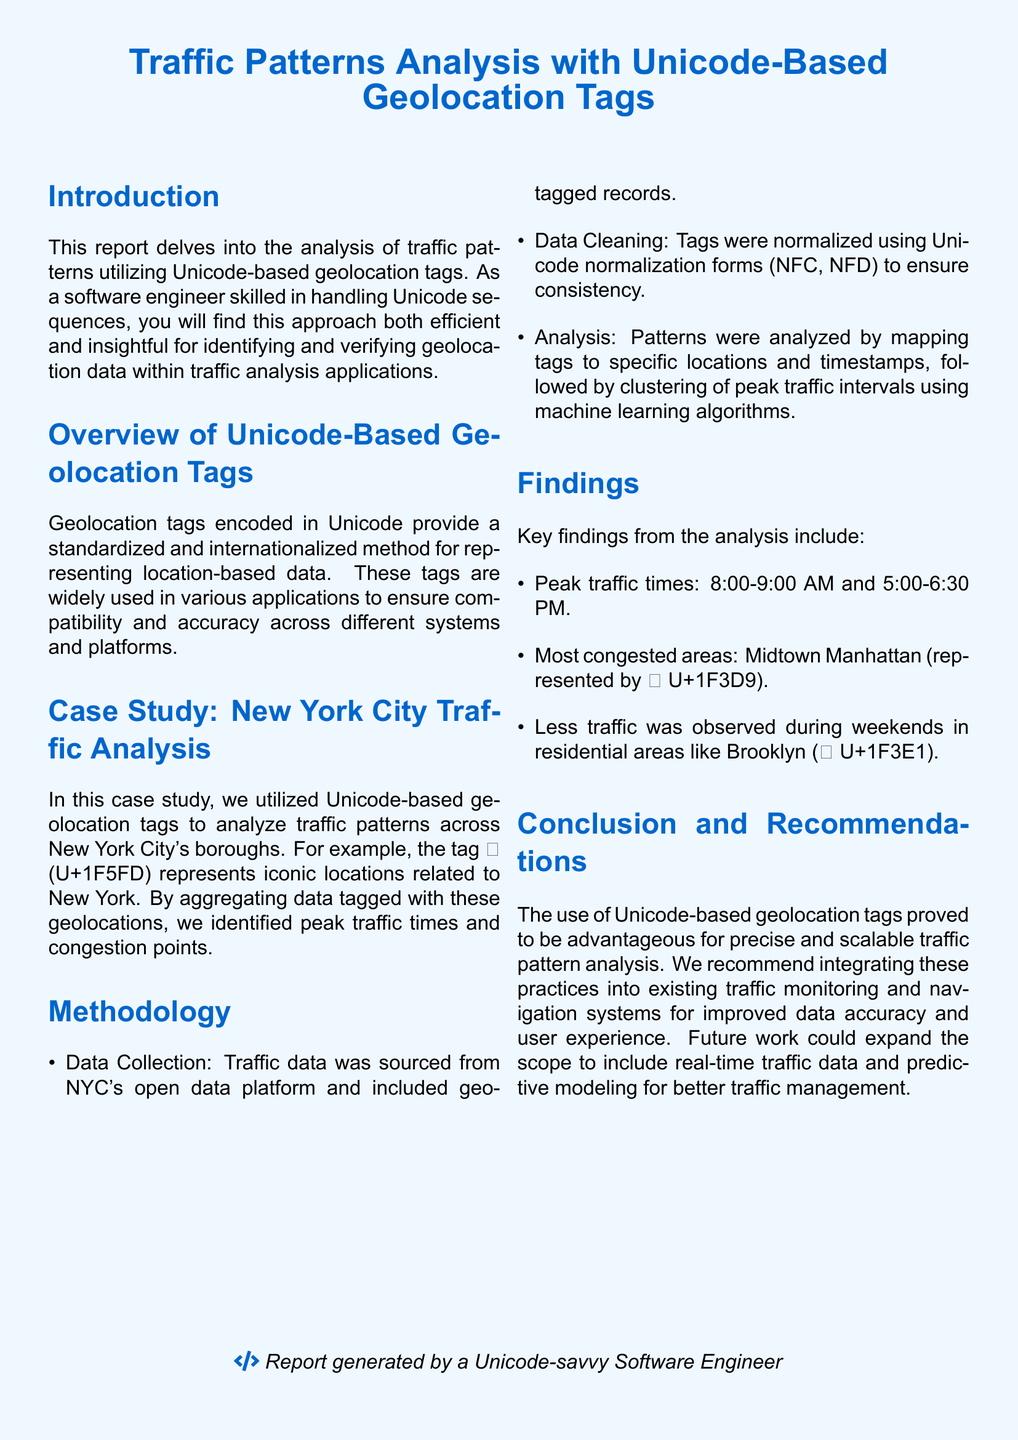What is the title of the report? The title of the report is found prominently at the top of the document.
Answer: Traffic Patterns Analysis with Unicode-Based Geolocation Tags What is the peak traffic time in the morning? The peak traffic time in the morning is mentioned in the findings section.
Answer: 8:00-9:00 AM Which borough showed less traffic during weekends? The section detailing findings specifies which area had less traffic on weekends.
Answer: Brooklyn What Unicode tag represents Midtown Manhattan? This tag is provided as part of the key findings regarding congested areas.
Answer: 🏙️ How was data normalization achieved? The methodology section describes the steps taken to ensure consistency in the data.
Answer: Unicode normalization forms What analysis method was used for peak traffic intervals? The report indicates the type of method applied for analyzing traffic patterns.
Answer: Machine learning algorithms Which category of vehicles was primarily analyzed? The report discusses the nature of the data collected from NYC's open data platform.
Answer: Traffic data What color is used for the report background? The color used for the page background is specified in the document setup.
Answer: Secondary color What is the main recommendation from the report? The conclusion section summarizes the primary suggestion for future actions.
Answer: Integrating Unicode-based practices 